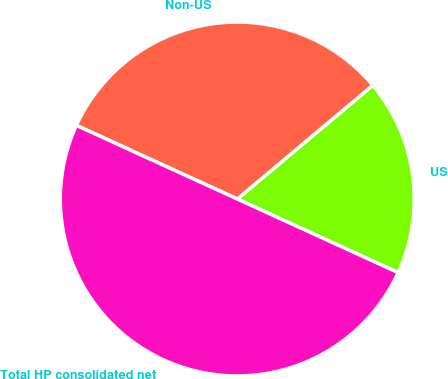Convert chart. <chart><loc_0><loc_0><loc_500><loc_500><pie_chart><fcel>US<fcel>Non-US<fcel>Total HP consolidated net<nl><fcel>17.94%<fcel>32.06%<fcel>50.0%<nl></chart> 